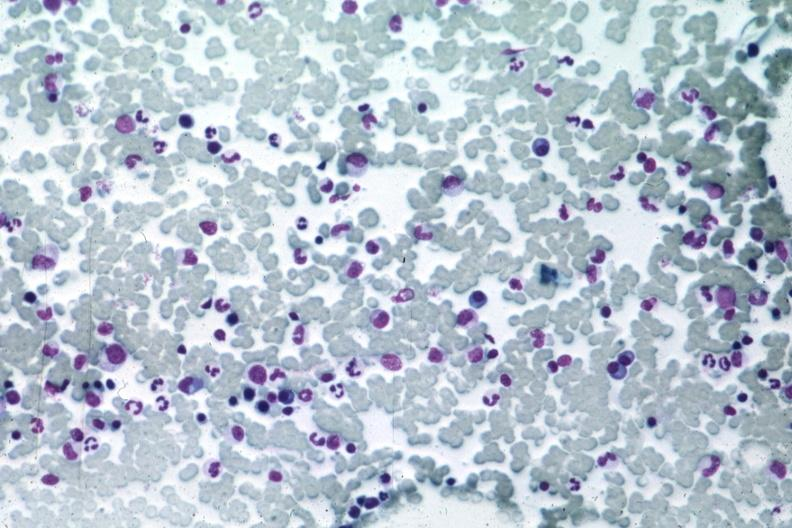s pituitary present?
Answer the question using a single word or phrase. No 